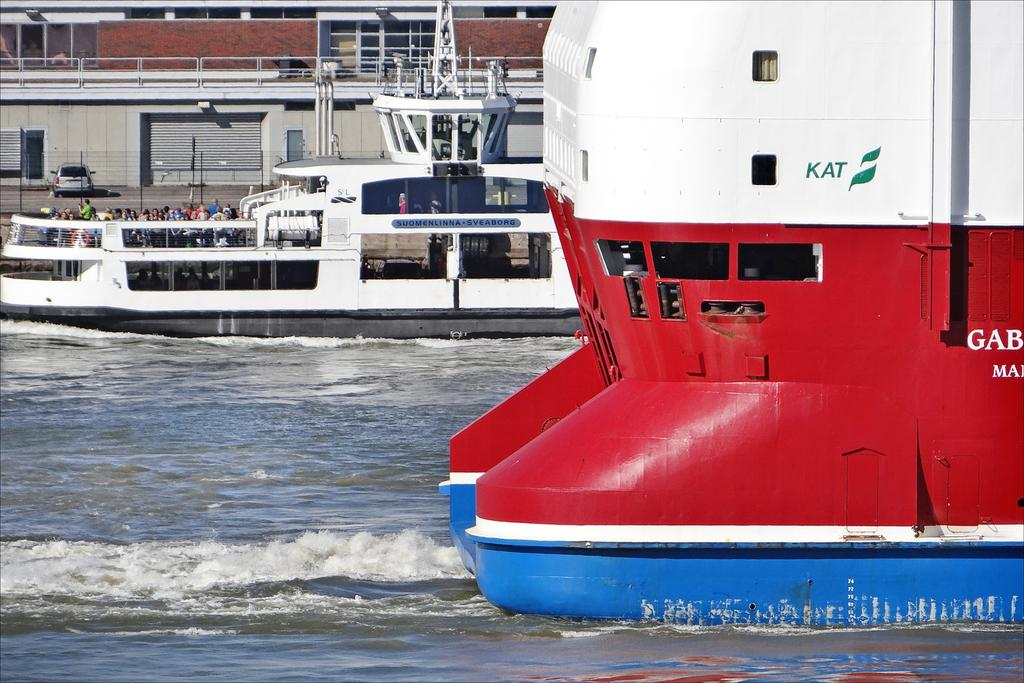<image>
Share a concise interpretation of the image provided. A red, yellow and blue ship has KAT is green paint above the rear windows. 